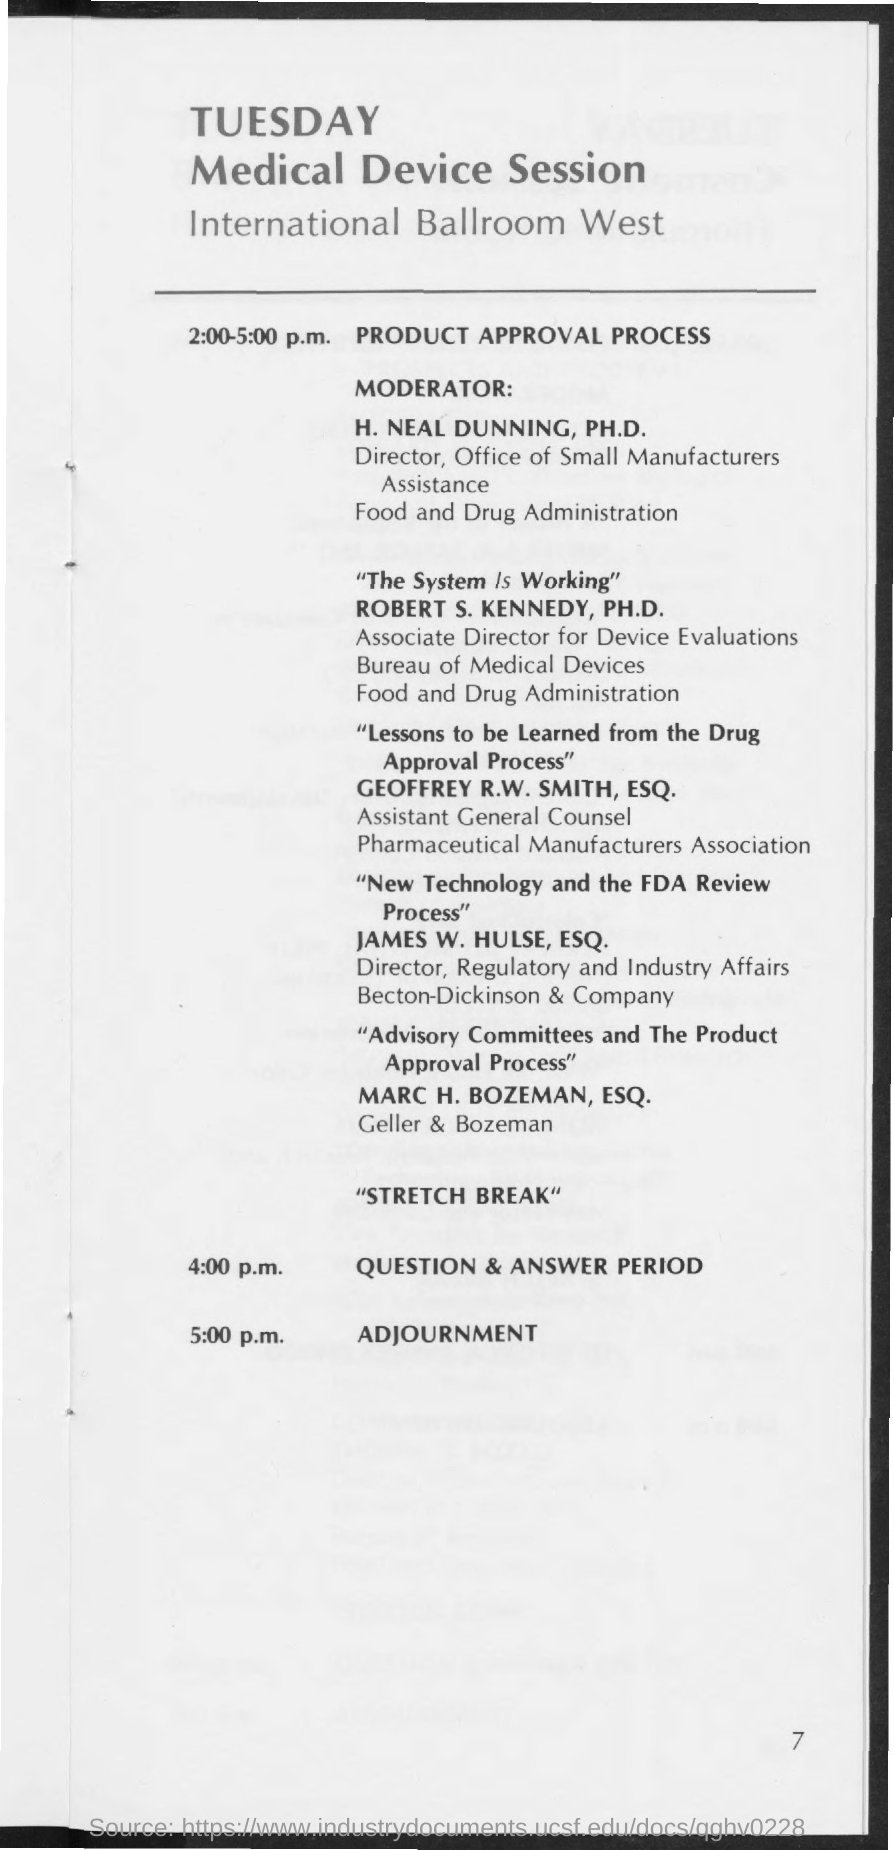When is the session for Product Approval Process?
Keep it short and to the point. 2:00-5:00 P.M. When is the Question & Answer Period?
Offer a very short reply. 4:00 p.m. When is the Adjournment?
Offer a terse response. 5:00 p.m. 